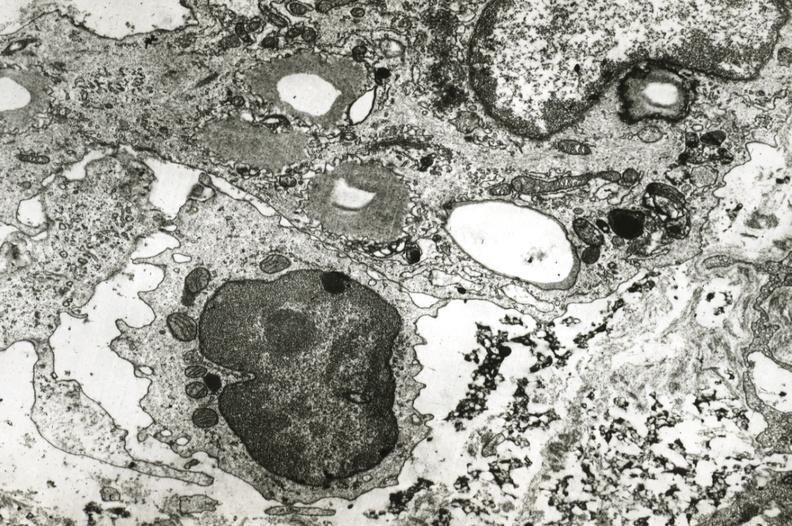s amyloidosis present?
Answer the question using a single word or phrase. No 